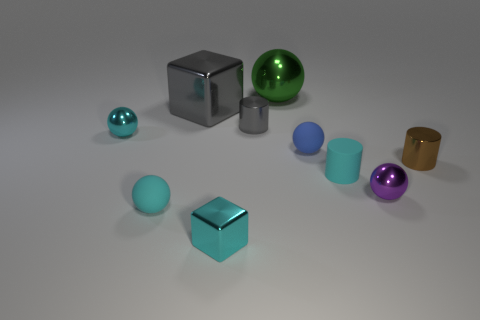Are there fewer brown shiny cylinders that are in front of the purple metal object than small cyan spheres?
Keep it short and to the point. Yes. What shape is the tiny matte object that is behind the cyan rubber cylinder?
Ensure brevity in your answer.  Sphere. What shape is the other shiny thing that is the same size as the green metal thing?
Provide a short and direct response. Cube. Are there any purple objects that have the same shape as the green thing?
Your answer should be compact. Yes. There is a rubber object on the left side of the tiny blue matte thing; is it the same shape as the small cyan object to the right of the big green metallic thing?
Offer a terse response. No. There is a gray block that is the same size as the green object; what material is it?
Make the answer very short. Metal. How many other things are the same material as the blue ball?
Your answer should be very brief. 2. What is the shape of the tiny cyan shiny object that is in front of the small cyan shiny ball behind the tiny purple object?
Provide a succinct answer. Cube. How many objects are either big balls or shiny things that are in front of the cyan metal sphere?
Ensure brevity in your answer.  4. How many other objects are there of the same color as the large ball?
Ensure brevity in your answer.  0. 